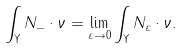<formula> <loc_0><loc_0><loc_500><loc_500>\int _ { \Upsilon } N _ { - } \cdot \nu = \lim _ { \varepsilon \rightarrow 0 } \int _ { \Upsilon } N _ { \varepsilon } \cdot \nu .</formula> 